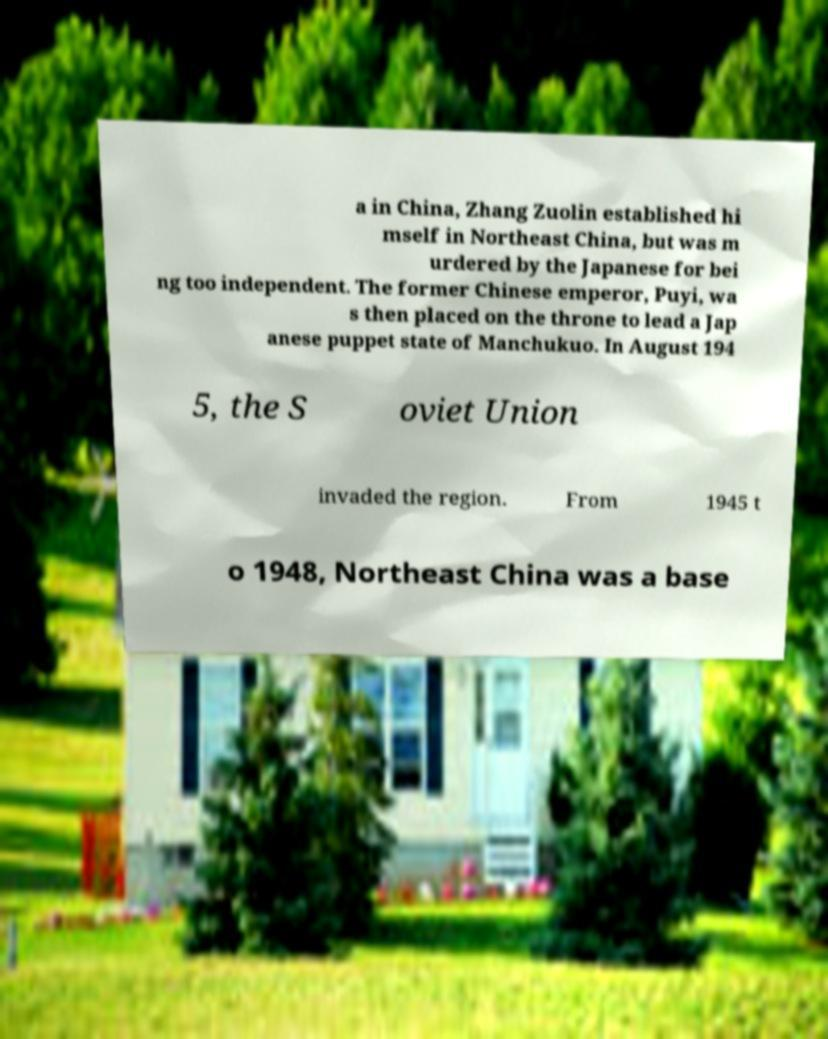Could you extract and type out the text from this image? a in China, Zhang Zuolin established hi mself in Northeast China, but was m urdered by the Japanese for bei ng too independent. The former Chinese emperor, Puyi, wa s then placed on the throne to lead a Jap anese puppet state of Manchukuo. In August 194 5, the S oviet Union invaded the region. From 1945 t o 1948, Northeast China was a base 